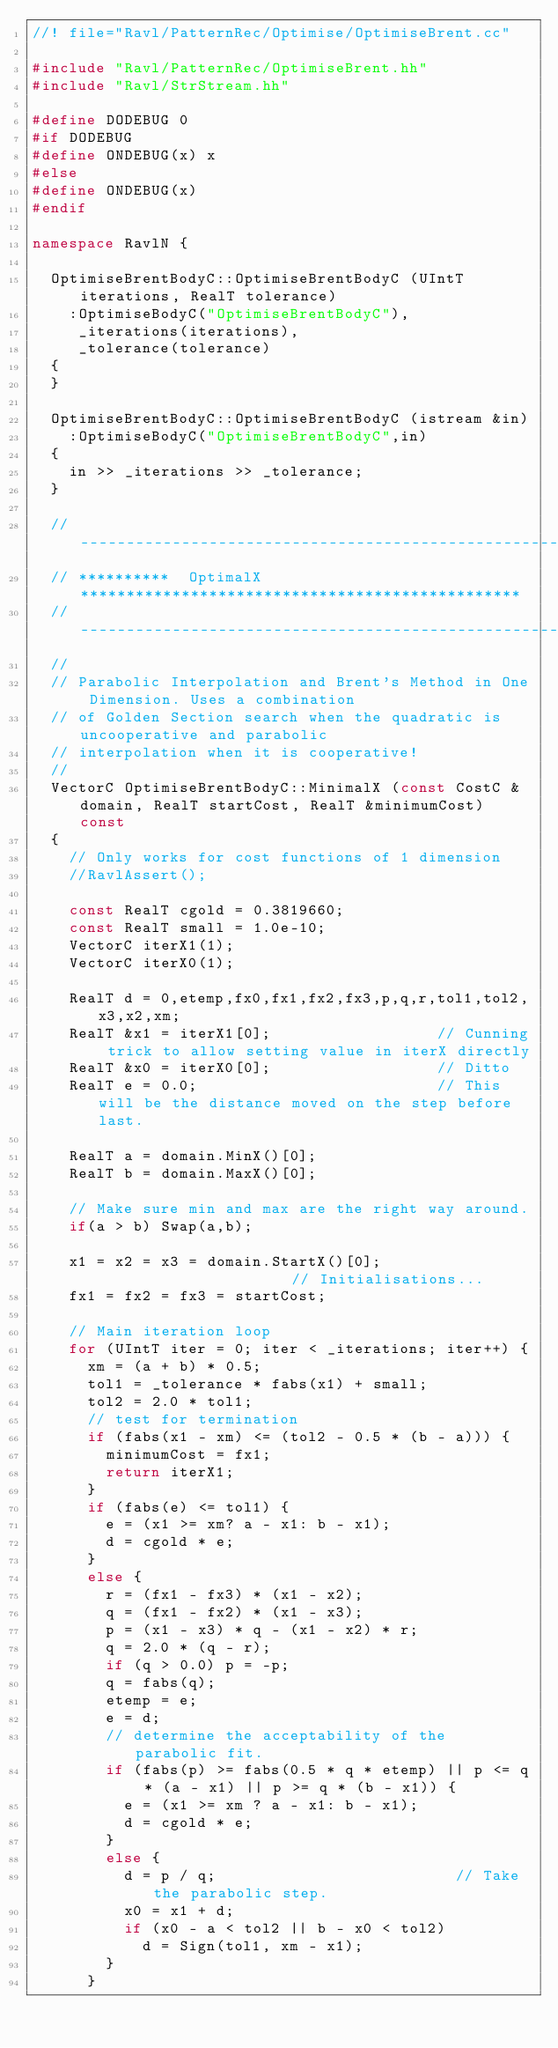Convert code to text. <code><loc_0><loc_0><loc_500><loc_500><_C++_>//! file="Ravl/PatternRec/Optimise/OptimiseBrent.cc"

#include "Ravl/PatternRec/OptimiseBrent.hh"
#include "Ravl/StrStream.hh"

#define DODEBUG 0
#if DODEBUG
#define ONDEBUG(x) x
#else
#define ONDEBUG(x)
#endif

namespace RavlN {

  OptimiseBrentBodyC::OptimiseBrentBodyC (UIntT iterations, RealT tolerance)
    :OptimiseBodyC("OptimiseBrentBodyC"),
     _iterations(iterations),
     _tolerance(tolerance)
  {
  }
  
  OptimiseBrentBodyC::OptimiseBrentBodyC (istream &in)
    :OptimiseBodyC("OptimiseBrentBodyC",in)
  {
    in >> _iterations >> _tolerance;
  }
  
  // ------------------------------------------------------------------------
  // **********  OptimalX    ************************************************
  // ------------------------------------------------------------------------
  //
  // Parabolic Interpolation and Brent's Method in One Dimension. Uses a combination
  // of Golden Section search when the quadratic is uncooperative and parabolic
  // interpolation when it is cooperative!
  //
  VectorC OptimiseBrentBodyC::MinimalX (const CostC &domain, RealT startCost, RealT &minimumCost) const
  {
    // Only works for cost functions of 1 dimension
    //RavlAssert();

    const RealT cgold = 0.3819660;
    const RealT small = 1.0e-10;
    VectorC iterX1(1);
    VectorC iterX0(1);

    RealT d = 0,etemp,fx0,fx1,fx2,fx3,p,q,r,tol1,tol2,x3,x2,xm;
    RealT &x1 = iterX1[0];                  // Cunning trick to allow setting value in iterX directly
    RealT &x0 = iterX0[0];                  // Ditto
    RealT e = 0.0;                          // This will be the distance moved on the step before last.
    
    RealT a = domain.MinX()[0];
    RealT b = domain.MaxX()[0];
    
    // Make sure min and max are the right way around.
    if(a > b) Swap(a,b);
    
    x1 = x2 = x3 = domain.StartX()[0];                      // Initialisations...
    fx1 = fx2 = fx3 = startCost;

    // Main iteration loop
    for (UIntT iter = 0; iter < _iterations; iter++) {
      xm = (a + b) * 0.5;
      tol1 = _tolerance * fabs(x1) + small;
      tol2 = 2.0 * tol1;
      // test for termination
      if (fabs(x1 - xm) <= (tol2 - 0.5 * (b - a))) {
        minimumCost = fx1;
        return iterX1;
      }
      if (fabs(e) <= tol1) {
        e = (x1 >= xm? a - x1: b - x1);
        d = cgold * e;
      }
      else {
        r = (fx1 - fx3) * (x1 - x2);
        q = (fx1 - fx2) * (x1 - x3);
        p = (x1 - x3) * q - (x1 - x2) * r;
        q = 2.0 * (q - r);
        if (q > 0.0) p = -p;
        q = fabs(q);
        etemp = e;
        e = d;
        // determine the acceptability of the parabolic fit.
        if (fabs(p) >= fabs(0.5 * q * etemp) || p <= q * (a - x1) || p >= q * (b - x1)) {
          e = (x1 >= xm ? a - x1: b - x1);
          d = cgold * e;
        }
        else {
          d = p / q;                          // Take the parabolic step.
          x0 = x1 + d;
          if (x0 - a < tol2 || b - x0 < tol2)
            d = Sign(tol1, xm - x1);
        }
      }</code> 